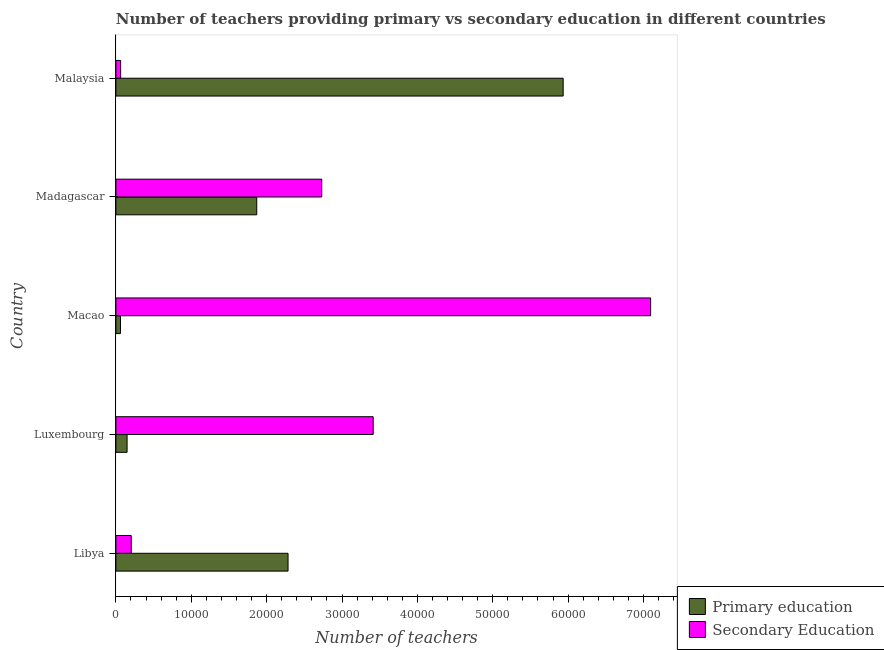How many groups of bars are there?
Keep it short and to the point. 5. How many bars are there on the 4th tick from the top?
Your response must be concise. 2. How many bars are there on the 1st tick from the bottom?
Keep it short and to the point. 2. What is the label of the 5th group of bars from the top?
Keep it short and to the point. Libya. What is the number of primary teachers in Madagascar?
Offer a very short reply. 1.87e+04. Across all countries, what is the maximum number of primary teachers?
Your response must be concise. 5.93e+04. Across all countries, what is the minimum number of secondary teachers?
Make the answer very short. 630. In which country was the number of secondary teachers maximum?
Offer a very short reply. Macao. In which country was the number of primary teachers minimum?
Offer a terse response. Macao. What is the total number of primary teachers in the graph?
Provide a succinct answer. 1.03e+05. What is the difference between the number of primary teachers in Madagascar and that in Malaysia?
Offer a terse response. -4.07e+04. What is the difference between the number of primary teachers in Luxembourg and the number of secondary teachers in Libya?
Make the answer very short. -550. What is the average number of secondary teachers per country?
Your response must be concise. 2.70e+04. What is the difference between the number of secondary teachers and number of primary teachers in Macao?
Make the answer very short. 7.03e+04. In how many countries, is the number of primary teachers greater than 36000 ?
Your answer should be very brief. 1. What is the ratio of the number of primary teachers in Libya to that in Malaysia?
Provide a short and direct response. 0.39. Is the difference between the number of secondary teachers in Luxembourg and Madagascar greater than the difference between the number of primary teachers in Luxembourg and Madagascar?
Offer a terse response. Yes. What is the difference between the highest and the second highest number of primary teachers?
Offer a very short reply. 3.65e+04. What is the difference between the highest and the lowest number of primary teachers?
Your response must be concise. 5.87e+04. In how many countries, is the number of secondary teachers greater than the average number of secondary teachers taken over all countries?
Keep it short and to the point. 3. Is the sum of the number of secondary teachers in Libya and Macao greater than the maximum number of primary teachers across all countries?
Provide a succinct answer. Yes. What does the 1st bar from the top in Luxembourg represents?
Your response must be concise. Secondary Education. What does the 1st bar from the bottom in Macao represents?
Your response must be concise. Primary education. Are all the bars in the graph horizontal?
Your answer should be compact. Yes. What is the difference between two consecutive major ticks on the X-axis?
Provide a short and direct response. 10000. Does the graph contain grids?
Ensure brevity in your answer.  No. Where does the legend appear in the graph?
Give a very brief answer. Bottom right. How are the legend labels stacked?
Provide a short and direct response. Vertical. What is the title of the graph?
Your response must be concise. Number of teachers providing primary vs secondary education in different countries. Does "US$" appear as one of the legend labels in the graph?
Your answer should be very brief. No. What is the label or title of the X-axis?
Make the answer very short. Number of teachers. What is the Number of teachers of Primary education in Libya?
Your response must be concise. 2.28e+04. What is the Number of teachers in Secondary Education in Libya?
Make the answer very short. 2034. What is the Number of teachers in Primary education in Luxembourg?
Keep it short and to the point. 1484. What is the Number of teachers of Secondary Education in Luxembourg?
Your answer should be very brief. 3.41e+04. What is the Number of teachers in Primary education in Macao?
Provide a succinct answer. 610. What is the Number of teachers in Secondary Education in Macao?
Provide a succinct answer. 7.09e+04. What is the Number of teachers in Primary education in Madagascar?
Your response must be concise. 1.87e+04. What is the Number of teachers in Secondary Education in Madagascar?
Make the answer very short. 2.73e+04. What is the Number of teachers of Primary education in Malaysia?
Your answer should be compact. 5.93e+04. What is the Number of teachers of Secondary Education in Malaysia?
Ensure brevity in your answer.  630. Across all countries, what is the maximum Number of teachers in Primary education?
Ensure brevity in your answer.  5.93e+04. Across all countries, what is the maximum Number of teachers of Secondary Education?
Provide a short and direct response. 7.09e+04. Across all countries, what is the minimum Number of teachers in Primary education?
Offer a very short reply. 610. Across all countries, what is the minimum Number of teachers of Secondary Education?
Provide a succinct answer. 630. What is the total Number of teachers of Primary education in the graph?
Ensure brevity in your answer.  1.03e+05. What is the total Number of teachers in Secondary Education in the graph?
Your answer should be compact. 1.35e+05. What is the difference between the Number of teachers in Primary education in Libya and that in Luxembourg?
Make the answer very short. 2.14e+04. What is the difference between the Number of teachers of Secondary Education in Libya and that in Luxembourg?
Offer a terse response. -3.21e+04. What is the difference between the Number of teachers of Primary education in Libya and that in Macao?
Keep it short and to the point. 2.22e+04. What is the difference between the Number of teachers of Secondary Education in Libya and that in Macao?
Provide a succinct answer. -6.89e+04. What is the difference between the Number of teachers in Primary education in Libya and that in Madagascar?
Offer a very short reply. 4154. What is the difference between the Number of teachers in Secondary Education in Libya and that in Madagascar?
Ensure brevity in your answer.  -2.53e+04. What is the difference between the Number of teachers of Primary education in Libya and that in Malaysia?
Your response must be concise. -3.65e+04. What is the difference between the Number of teachers of Secondary Education in Libya and that in Malaysia?
Give a very brief answer. 1404. What is the difference between the Number of teachers in Primary education in Luxembourg and that in Macao?
Offer a very short reply. 874. What is the difference between the Number of teachers of Secondary Education in Luxembourg and that in Macao?
Your answer should be very brief. -3.68e+04. What is the difference between the Number of teachers in Primary education in Luxembourg and that in Madagascar?
Your answer should be compact. -1.72e+04. What is the difference between the Number of teachers of Secondary Education in Luxembourg and that in Madagascar?
Your answer should be compact. 6824. What is the difference between the Number of teachers of Primary education in Luxembourg and that in Malaysia?
Your answer should be compact. -5.79e+04. What is the difference between the Number of teachers of Secondary Education in Luxembourg and that in Malaysia?
Provide a short and direct response. 3.35e+04. What is the difference between the Number of teachers of Primary education in Macao and that in Madagascar?
Ensure brevity in your answer.  -1.81e+04. What is the difference between the Number of teachers of Secondary Education in Macao and that in Madagascar?
Offer a terse response. 4.36e+04. What is the difference between the Number of teachers of Primary education in Macao and that in Malaysia?
Provide a succinct answer. -5.87e+04. What is the difference between the Number of teachers in Secondary Education in Macao and that in Malaysia?
Offer a very short reply. 7.03e+04. What is the difference between the Number of teachers in Primary education in Madagascar and that in Malaysia?
Give a very brief answer. -4.07e+04. What is the difference between the Number of teachers in Secondary Education in Madagascar and that in Malaysia?
Provide a succinct answer. 2.67e+04. What is the difference between the Number of teachers of Primary education in Libya and the Number of teachers of Secondary Education in Luxembourg?
Give a very brief answer. -1.13e+04. What is the difference between the Number of teachers in Primary education in Libya and the Number of teachers in Secondary Education in Macao?
Your answer should be compact. -4.81e+04. What is the difference between the Number of teachers of Primary education in Libya and the Number of teachers of Secondary Education in Madagascar?
Your answer should be very brief. -4470. What is the difference between the Number of teachers of Primary education in Libya and the Number of teachers of Secondary Education in Malaysia?
Your answer should be compact. 2.22e+04. What is the difference between the Number of teachers in Primary education in Luxembourg and the Number of teachers in Secondary Education in Macao?
Your answer should be very brief. -6.95e+04. What is the difference between the Number of teachers of Primary education in Luxembourg and the Number of teachers of Secondary Education in Madagascar?
Keep it short and to the point. -2.58e+04. What is the difference between the Number of teachers of Primary education in Luxembourg and the Number of teachers of Secondary Education in Malaysia?
Keep it short and to the point. 854. What is the difference between the Number of teachers of Primary education in Macao and the Number of teachers of Secondary Education in Madagascar?
Your answer should be very brief. -2.67e+04. What is the difference between the Number of teachers in Primary education in Madagascar and the Number of teachers in Secondary Education in Malaysia?
Ensure brevity in your answer.  1.81e+04. What is the average Number of teachers in Primary education per country?
Give a very brief answer. 2.06e+04. What is the average Number of teachers of Secondary Education per country?
Provide a short and direct response. 2.70e+04. What is the difference between the Number of teachers of Primary education and Number of teachers of Secondary Education in Libya?
Give a very brief answer. 2.08e+04. What is the difference between the Number of teachers of Primary education and Number of teachers of Secondary Education in Luxembourg?
Ensure brevity in your answer.  -3.27e+04. What is the difference between the Number of teachers in Primary education and Number of teachers in Secondary Education in Macao?
Offer a terse response. -7.03e+04. What is the difference between the Number of teachers in Primary education and Number of teachers in Secondary Education in Madagascar?
Provide a succinct answer. -8624. What is the difference between the Number of teachers of Primary education and Number of teachers of Secondary Education in Malaysia?
Keep it short and to the point. 5.87e+04. What is the ratio of the Number of teachers of Primary education in Libya to that in Luxembourg?
Keep it short and to the point. 15.39. What is the ratio of the Number of teachers of Secondary Education in Libya to that in Luxembourg?
Your answer should be very brief. 0.06. What is the ratio of the Number of teachers in Primary education in Libya to that in Macao?
Provide a short and direct response. 37.45. What is the ratio of the Number of teachers in Secondary Education in Libya to that in Macao?
Offer a very short reply. 0.03. What is the ratio of the Number of teachers in Primary education in Libya to that in Madagascar?
Make the answer very short. 1.22. What is the ratio of the Number of teachers in Secondary Education in Libya to that in Madagascar?
Your answer should be compact. 0.07. What is the ratio of the Number of teachers in Primary education in Libya to that in Malaysia?
Offer a terse response. 0.38. What is the ratio of the Number of teachers of Secondary Education in Libya to that in Malaysia?
Ensure brevity in your answer.  3.23. What is the ratio of the Number of teachers of Primary education in Luxembourg to that in Macao?
Give a very brief answer. 2.43. What is the ratio of the Number of teachers of Secondary Education in Luxembourg to that in Macao?
Provide a succinct answer. 0.48. What is the ratio of the Number of teachers of Primary education in Luxembourg to that in Madagascar?
Provide a succinct answer. 0.08. What is the ratio of the Number of teachers in Secondary Education in Luxembourg to that in Madagascar?
Keep it short and to the point. 1.25. What is the ratio of the Number of teachers in Primary education in Luxembourg to that in Malaysia?
Offer a very short reply. 0.03. What is the ratio of the Number of teachers of Secondary Education in Luxembourg to that in Malaysia?
Your answer should be very brief. 54.18. What is the ratio of the Number of teachers in Primary education in Macao to that in Madagascar?
Make the answer very short. 0.03. What is the ratio of the Number of teachers of Secondary Education in Macao to that in Madagascar?
Provide a succinct answer. 2.6. What is the ratio of the Number of teachers in Primary education in Macao to that in Malaysia?
Offer a terse response. 0.01. What is the ratio of the Number of teachers in Secondary Education in Macao to that in Malaysia?
Make the answer very short. 112.61. What is the ratio of the Number of teachers of Primary education in Madagascar to that in Malaysia?
Your answer should be compact. 0.31. What is the ratio of the Number of teachers in Secondary Education in Madagascar to that in Malaysia?
Your answer should be compact. 43.35. What is the difference between the highest and the second highest Number of teachers in Primary education?
Your response must be concise. 3.65e+04. What is the difference between the highest and the second highest Number of teachers of Secondary Education?
Ensure brevity in your answer.  3.68e+04. What is the difference between the highest and the lowest Number of teachers of Primary education?
Ensure brevity in your answer.  5.87e+04. What is the difference between the highest and the lowest Number of teachers in Secondary Education?
Your response must be concise. 7.03e+04. 